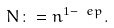<formula> <loc_0><loc_0><loc_500><loc_500>N \colon = n ^ { 1 - \ e p } .</formula> 